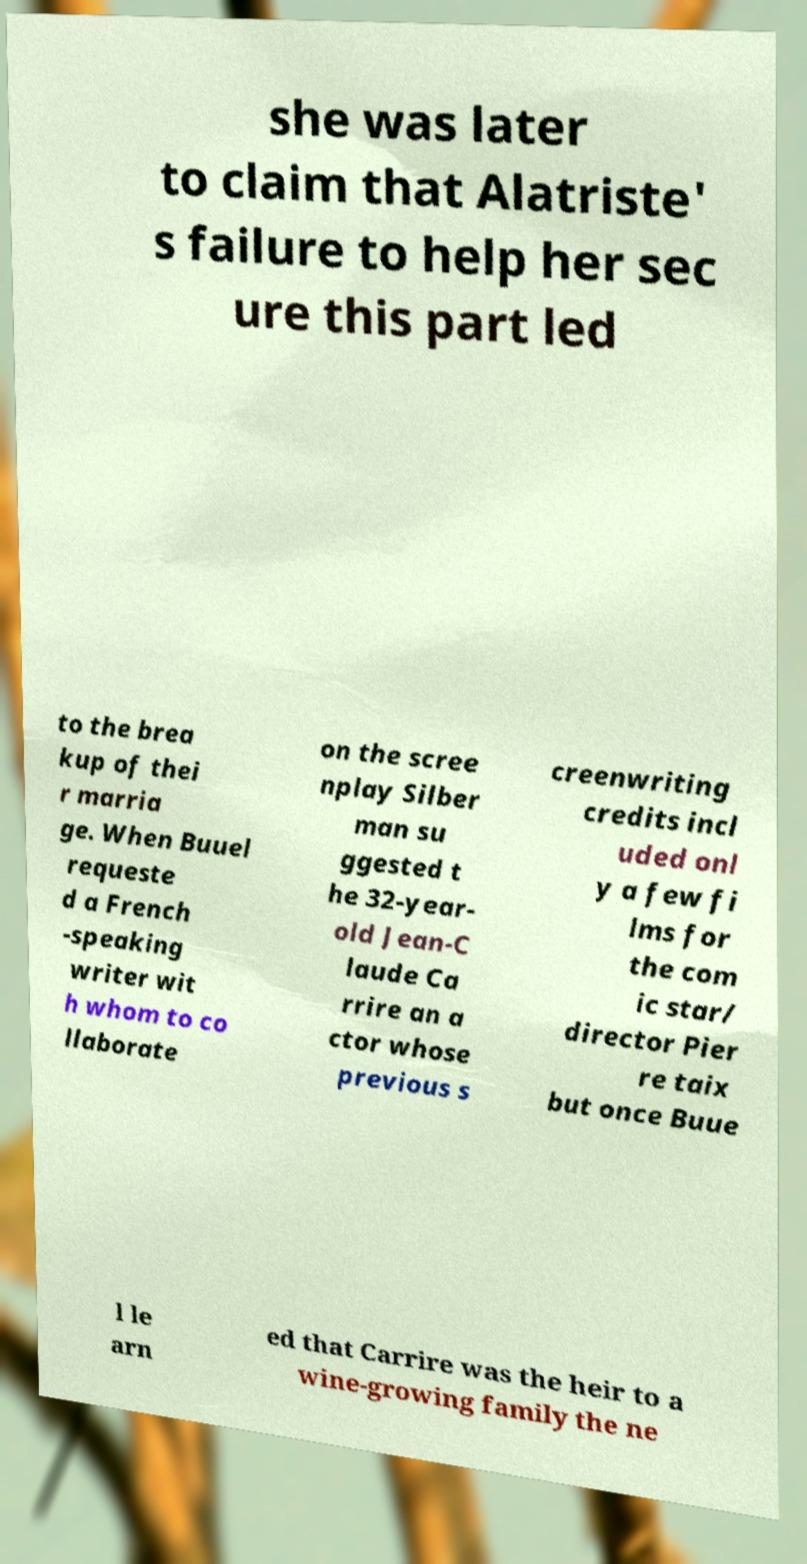Could you extract and type out the text from this image? she was later to claim that Alatriste' s failure to help her sec ure this part led to the brea kup of thei r marria ge. When Buuel requeste d a French -speaking writer wit h whom to co llaborate on the scree nplay Silber man su ggested t he 32-year- old Jean-C laude Ca rrire an a ctor whose previous s creenwriting credits incl uded onl y a few fi lms for the com ic star/ director Pier re taix but once Buue l le arn ed that Carrire was the heir to a wine-growing family the ne 